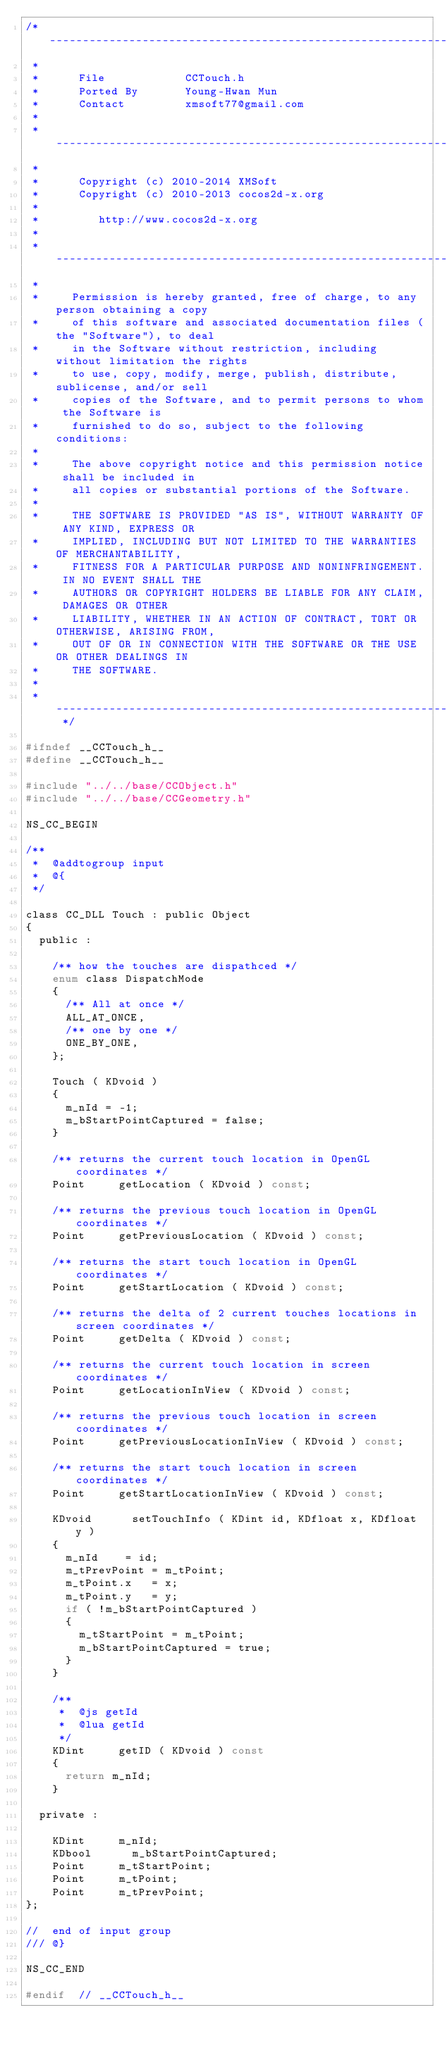<code> <loc_0><loc_0><loc_500><loc_500><_C_>/* -----------------------------------------------------------------------------------
 *
 *      File            CCTouch.h
 *      Ported By       Young-Hwan Mun
 *      Contact         xmsoft77@gmail.com 
 * 
 * -----------------------------------------------------------------------------------
 *   
 *      Copyright (c) 2010-2014 XMSoft
 *      Copyright (c) 2010-2013 cocos2d-x.org
 *
 *         http://www.cocos2d-x.org      
 *
 * -----------------------------------------------------------------------------------
 * 
 *     Permission is hereby granted, free of charge, to any person obtaining a copy
 *     of this software and associated documentation files (the "Software"), to deal
 *     in the Software without restriction, including without limitation the rights
 *     to use, copy, modify, merge, publish, distribute, sublicense, and/or sell
 *     copies of the Software, and to permit persons to whom the Software is
 *     furnished to do so, subject to the following conditions:
 *
 *     The above copyright notice and this permission notice shall be included in
 *     all copies or substantial portions of the Software.
 *     
 *     THE SOFTWARE IS PROVIDED "AS IS", WITHOUT WARRANTY OF ANY KIND, EXPRESS OR
 *     IMPLIED, INCLUDING BUT NOT LIMITED TO THE WARRANTIES OF MERCHANTABILITY,
 *     FITNESS FOR A PARTICULAR PURPOSE AND NONINFRINGEMENT. IN NO EVENT SHALL THE
 *     AUTHORS OR COPYRIGHT HOLDERS BE LIABLE FOR ANY CLAIM, DAMAGES OR OTHER
 *     LIABILITY, WHETHER IN AN ACTION OF CONTRACT, TORT OR OTHERWISE, ARISING FROM,
 *     OUT OF OR IN CONNECTION WITH THE SOFTWARE OR THE USE OR OTHER DEALINGS IN
 *     THE SOFTWARE.
 *
 * --------------------------------------------------------------------------------- */ 

#ifndef __CCTouch_h__
#define __CCTouch_h__

#include "../../base/CCObject.h"
#include "../../base/CCGeometry.h"

NS_CC_BEGIN

/**
 *	@addtogroup input
 *	@{
 */

class CC_DLL Touch : public Object
{
	public :

		/** how the touches are dispathced */
		enum class DispatchMode 
		{
			/** All at once */
			ALL_AT_ONCE,
			/** one by one */
			ONE_BY_ONE,
		};

		Touch ( KDvoid ) 
		{
			m_nId = -1;
			m_bStartPointCaptured = false;
		}

		/** returns the current touch location in OpenGL coordinates */
		Point			getLocation ( KDvoid ) const;
		
		/** returns the previous touch location in OpenGL coordinates */
		Point			getPreviousLocation ( KDvoid ) const;
		
		/** returns the start touch location in OpenGL coordinates */
		Point			getStartLocation ( KDvoid ) const;
		
		/** returns the delta of 2 current touches locations in screen coordinates */
		Point			getDelta ( KDvoid ) const;
		
		/** returns the current touch location in screen coordinates */
		Point			getLocationInView ( KDvoid ) const;
		
		/** returns the previous touch location in screen coordinates */
		Point			getPreviousLocationInView ( KDvoid ) const;

		/** returns the start touch location in screen coordinates */
		Point			getStartLocationInView ( KDvoid ) const;
    
		KDvoid			setTouchInfo ( KDint id, KDfloat x, KDfloat y )
		{
			m_nId		 = id;
			m_tPrevPoint = m_tPoint;
			m_tPoint.x   = x;
			m_tPoint.y   = y;
			if ( !m_bStartPointCaptured )
			{
				m_tStartPoint = m_tPoint;
				m_bStartPointCaptured = true;
			}
		}

		/**
		 *	@js getId
		 *	@lua getId
		 */
		KDint			getID ( KDvoid ) const
		{
			return m_nId;
		}

	private :

		KDint			m_nId;
		KDbool			m_bStartPointCaptured;
		Point			m_tStartPoint;
		Point			m_tPoint;
		Point			m_tPrevPoint;
};

//	end of input group
/// @}

NS_CC_END

#endif  // __CCTouch_h__
</code> 